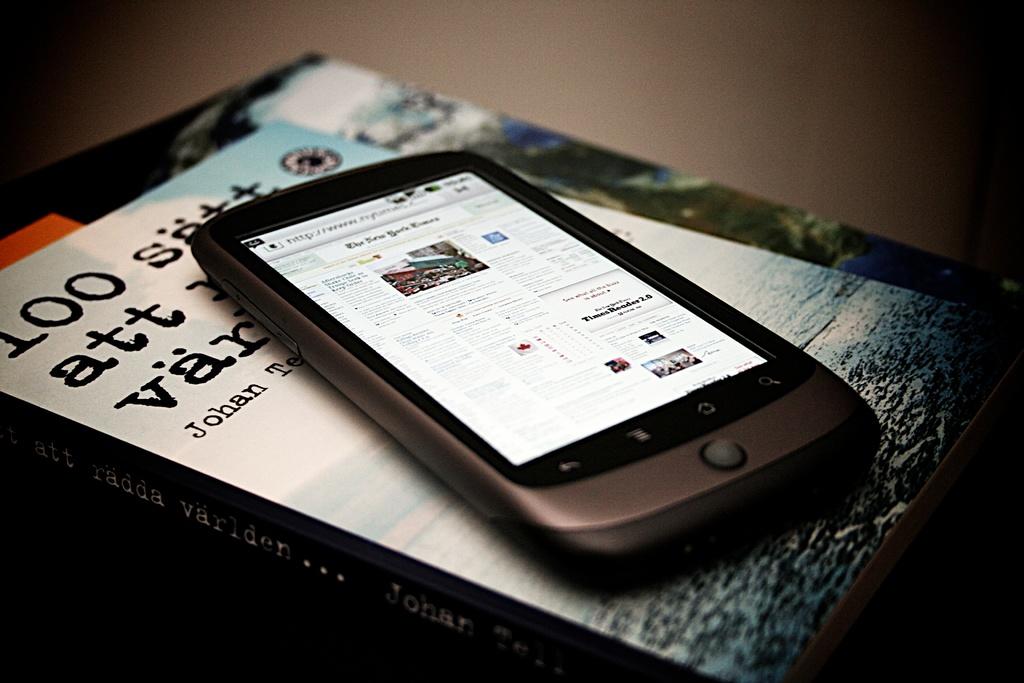Who wrote that book?
Your answer should be compact. Johan. 